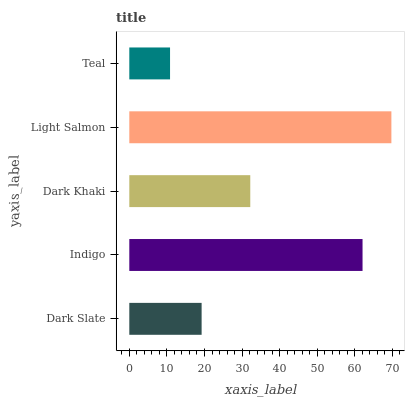Is Teal the minimum?
Answer yes or no. Yes. Is Light Salmon the maximum?
Answer yes or no. Yes. Is Indigo the minimum?
Answer yes or no. No. Is Indigo the maximum?
Answer yes or no. No. Is Indigo greater than Dark Slate?
Answer yes or no. Yes. Is Dark Slate less than Indigo?
Answer yes or no. Yes. Is Dark Slate greater than Indigo?
Answer yes or no. No. Is Indigo less than Dark Slate?
Answer yes or no. No. Is Dark Khaki the high median?
Answer yes or no. Yes. Is Dark Khaki the low median?
Answer yes or no. Yes. Is Indigo the high median?
Answer yes or no. No. Is Dark Slate the low median?
Answer yes or no. No. 